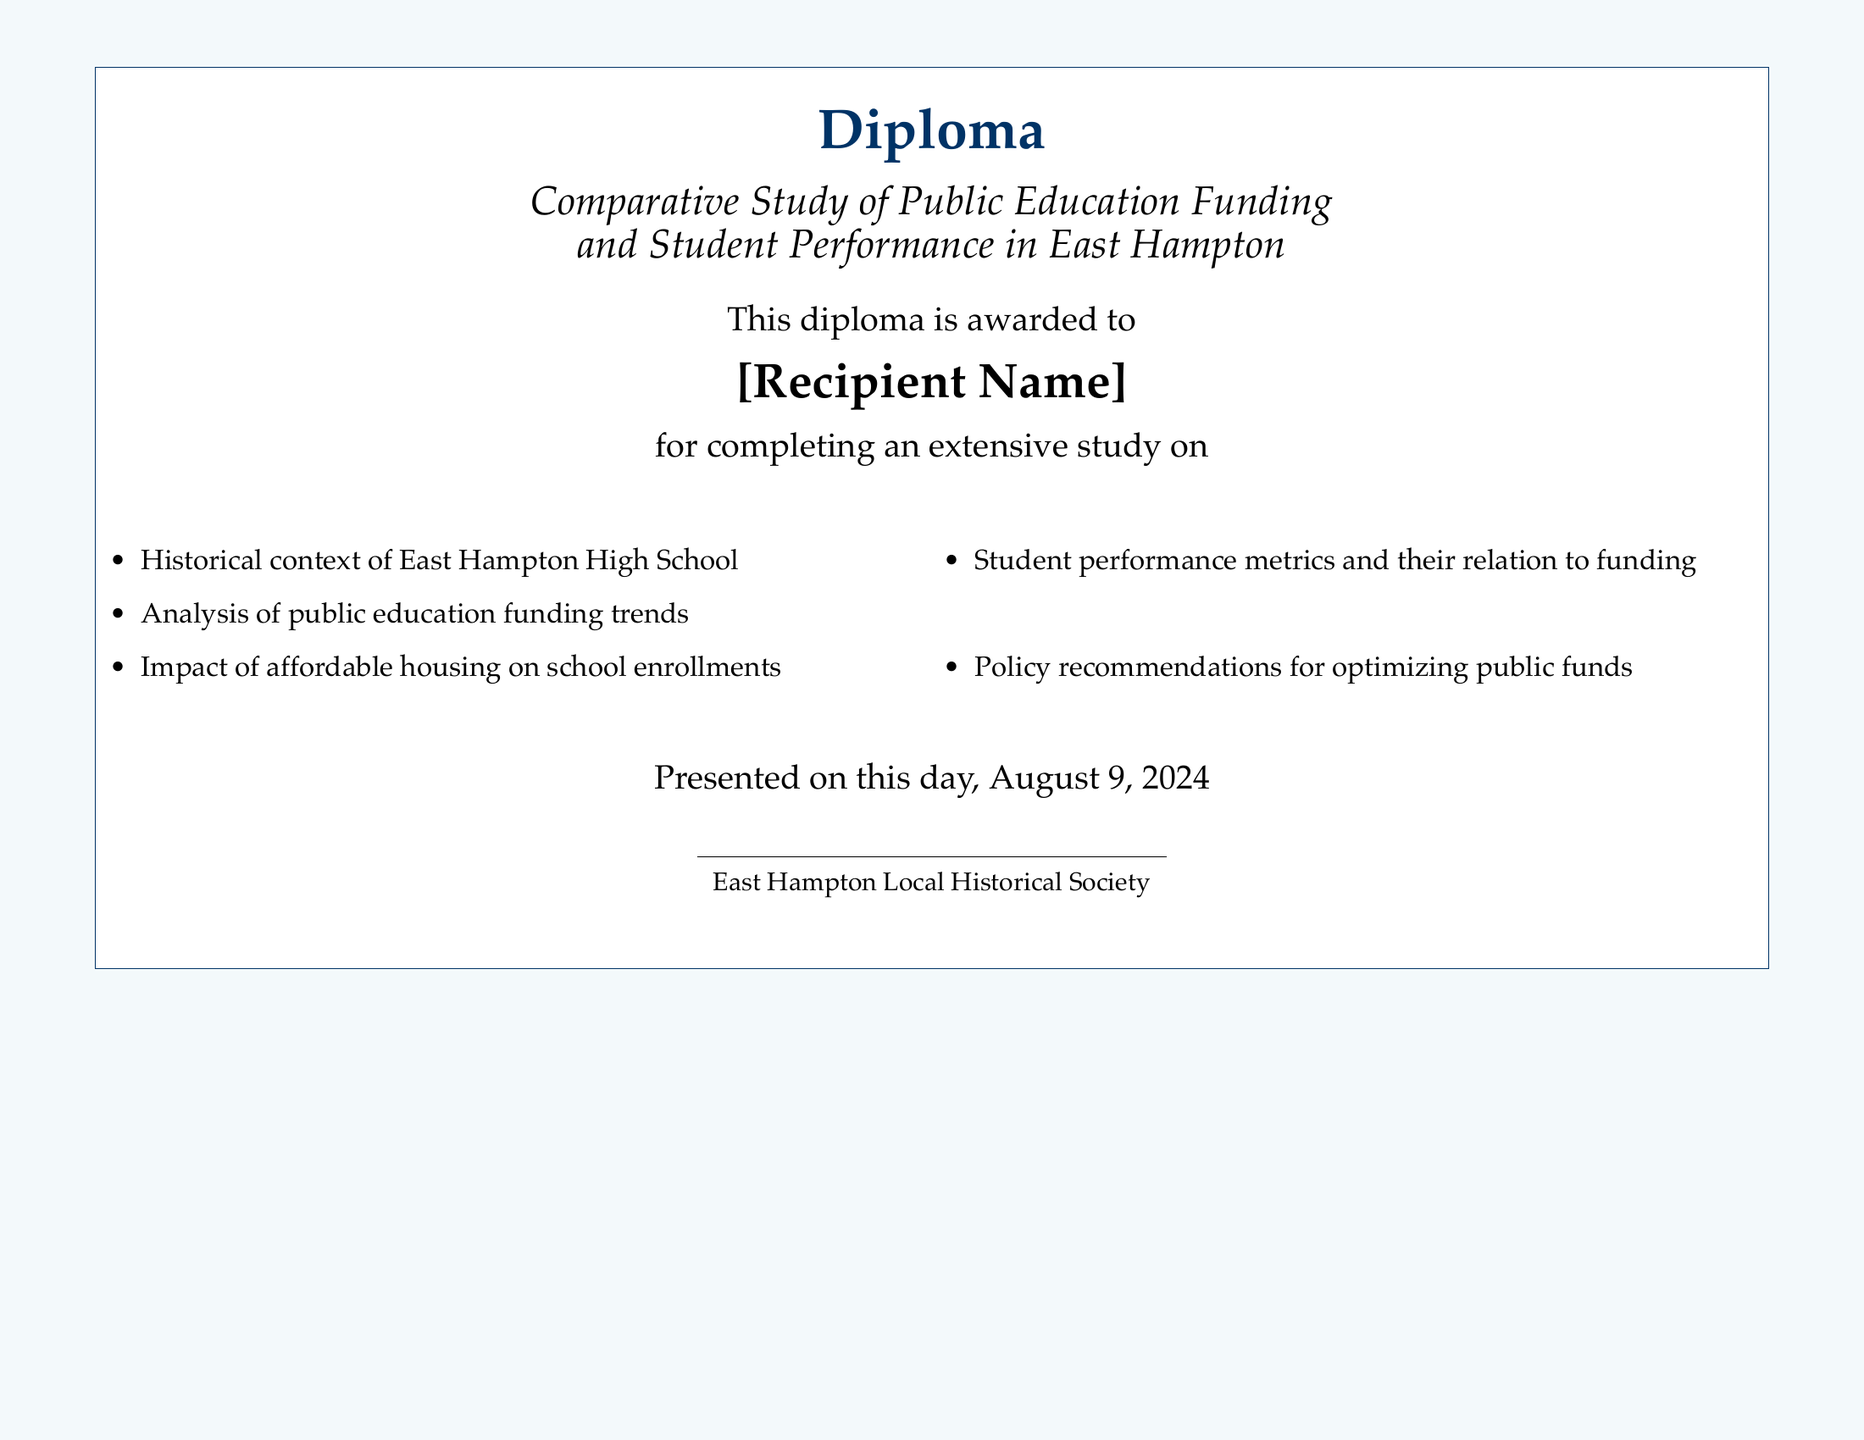What is the title of the diploma? The title is stated prominently within the document, mentioning the study's focus.
Answer: Comparative Study of Public Education Funding and Student Performance in East Hampton Who is the recipient of the diploma? The document has a placeholder for the recipient's name, indicating this is a personalized recognition.
Answer: [Recipient Name] What organization presented the diploma? The document credits the organization responsible for the diploma's presentation.
Answer: East Hampton Local Historical Society What is one topic covered in the study? The document lists various topics explored in the diploma, indicating key areas of focus.
Answer: Impact of affordable housing on school enrollments On what date was the diploma presented? The presentation date is included in the document as a placeholder for the day it was issued.
Answer: \today What is the significance of the analysis of public education funding? This analysis is one of the key components, indicating its importance in the study.
Answer: Public education funding trends How many areas are listed in the diploma? The diploma enumerates the topics covered in the study, providing an overview of the research.
Answer: Five 